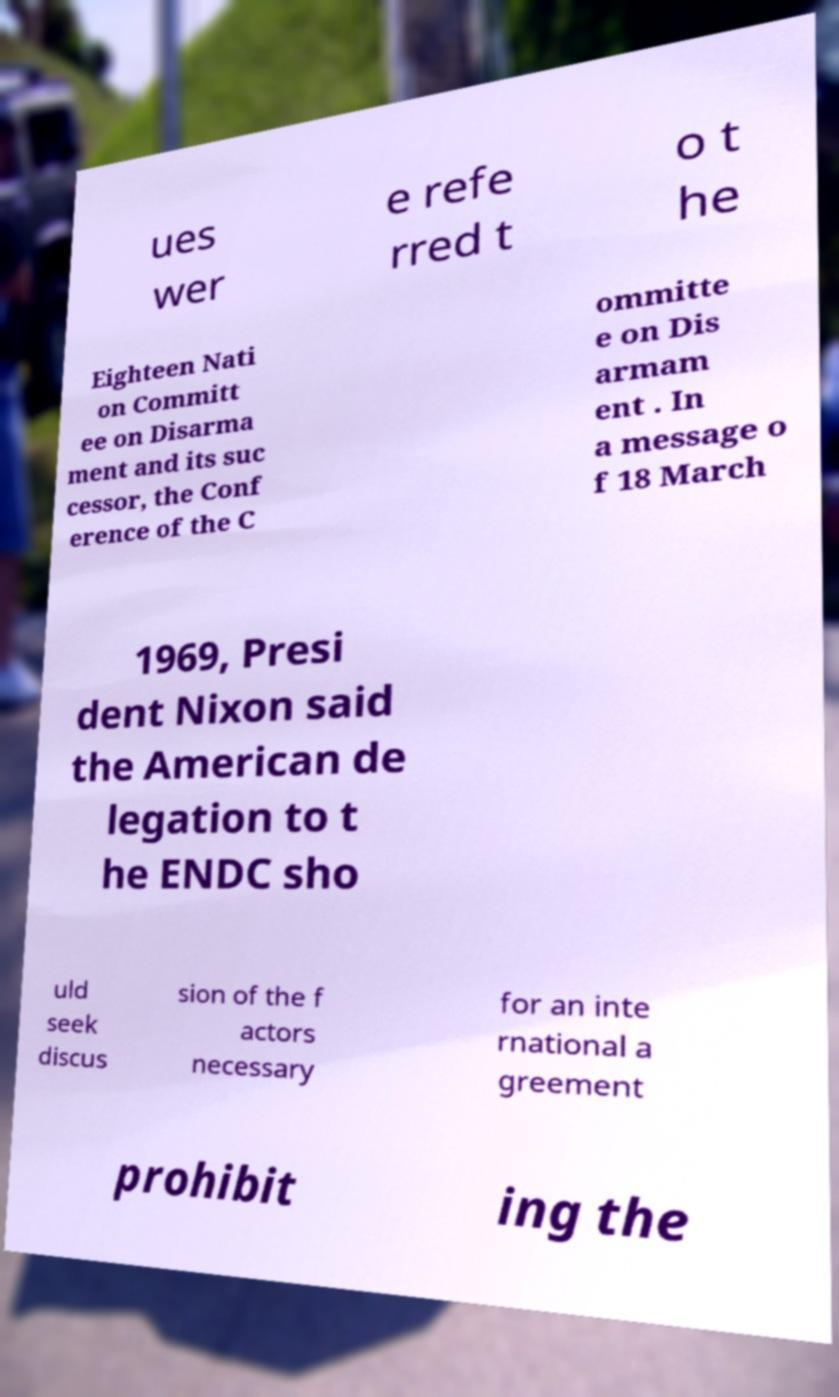Could you assist in decoding the text presented in this image and type it out clearly? ues wer e refe rred t o t he Eighteen Nati on Committ ee on Disarma ment and its suc cessor, the Conf erence of the C ommitte e on Dis armam ent . In a message o f 18 March 1969, Presi dent Nixon said the American de legation to t he ENDC sho uld seek discus sion of the f actors necessary for an inte rnational a greement prohibit ing the 